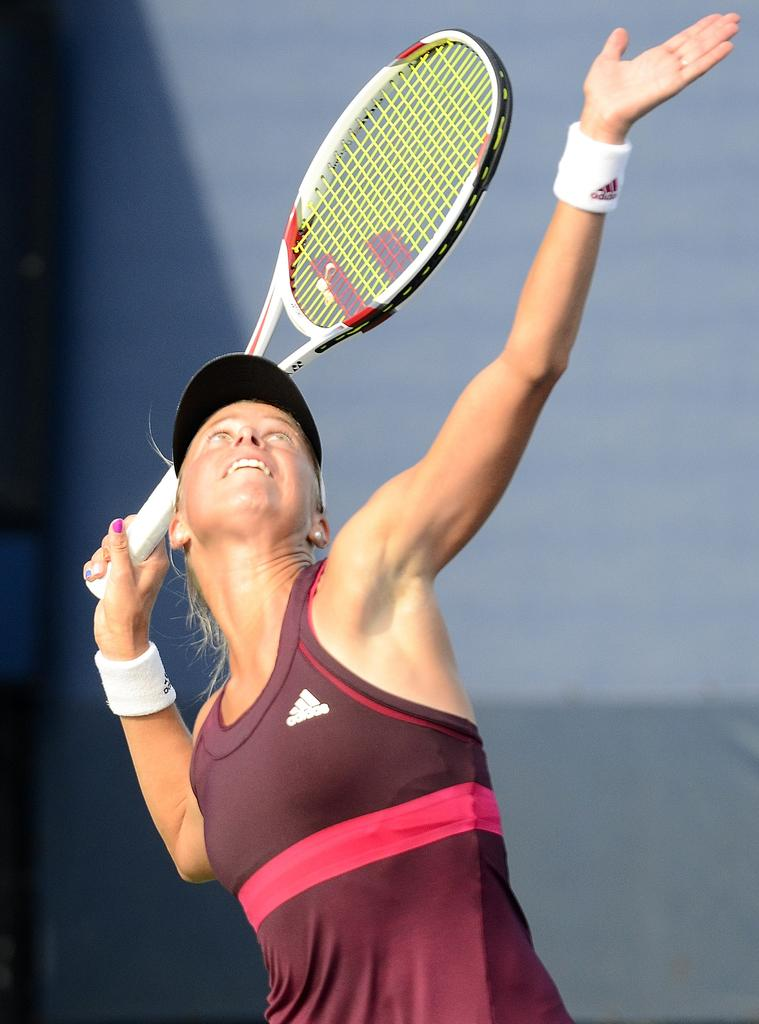Who is the main subject in the image? There is a woman in the image. Where is the woman positioned in the image? The woman is standing in the middle of the image. What is the woman holding in the image? The woman is holding a tennis racket. What can be seen behind the woman in the image? There is a wall behind the woman. What type of verse is being recited by the woman in the image? There is no indication in the image that the woman is reciting a verse, as she is holding a tennis racket and there is no mention of any poetry or literature. 